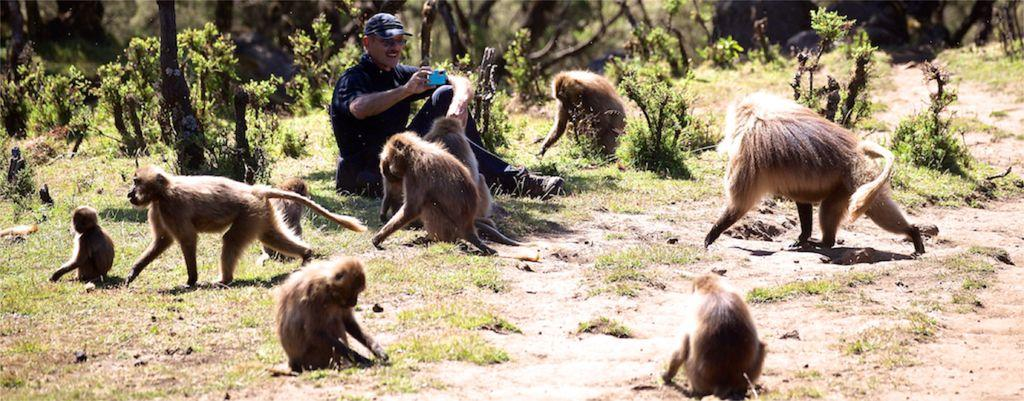Who is present in the image? There is a man in the image. What else can be seen in the image besides the man? There are monkeys in the image. Where is the man seated? The man is seated on the grass. What is the man doing in the image? The man is using a camera. What can be seen in the background of the image? There are trees in the background of the image. What type of alarm is the man using to take pictures of the monkeys? There is no alarm present in the image; the man is using a camera to take pictures. 